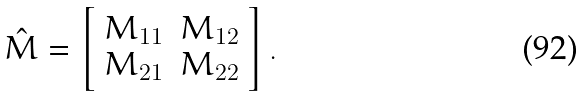<formula> <loc_0><loc_0><loc_500><loc_500>\hat { M } = \left [ \begin{array} { c c } M _ { 1 1 } & M _ { 1 2 } \\ M _ { 2 1 } & M _ { 2 2 } \end{array} \right ] .</formula> 